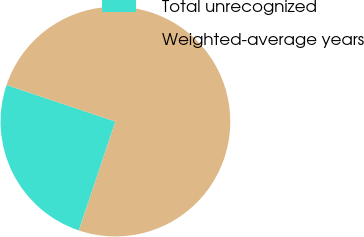Convert chart. <chart><loc_0><loc_0><loc_500><loc_500><pie_chart><fcel>Total unrecognized<fcel>Weighted-average years<nl><fcel>25.0%<fcel>75.0%<nl></chart> 